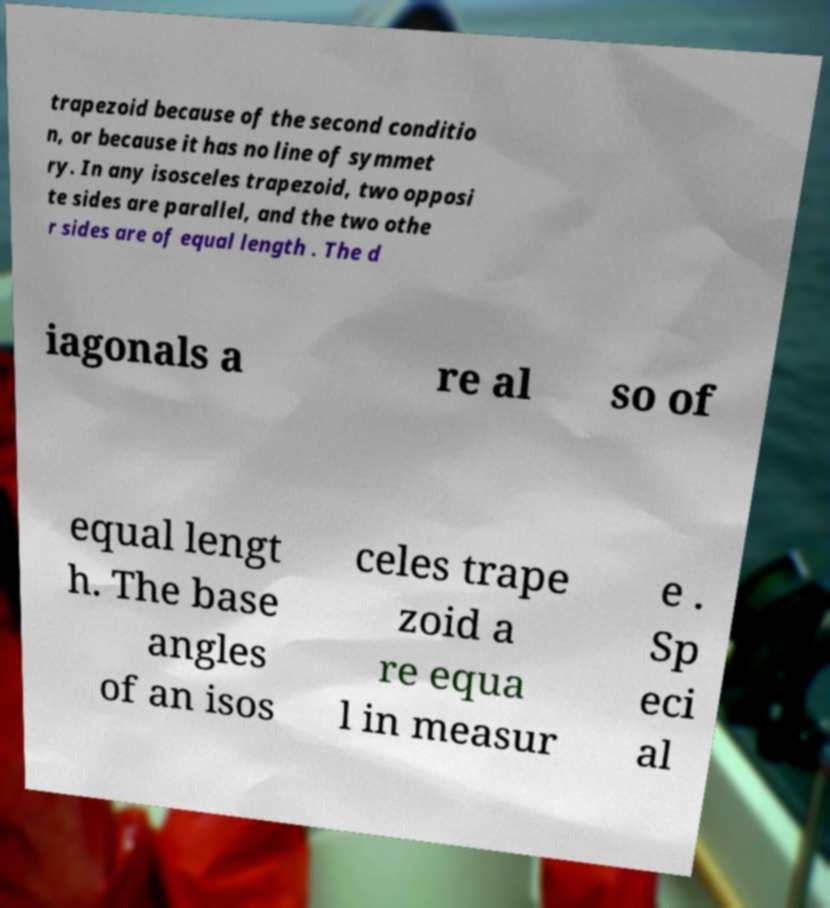Could you assist in decoding the text presented in this image and type it out clearly? trapezoid because of the second conditio n, or because it has no line of symmet ry. In any isosceles trapezoid, two opposi te sides are parallel, and the two othe r sides are of equal length . The d iagonals a re al so of equal lengt h. The base angles of an isos celes trape zoid a re equa l in measur e . Sp eci al 